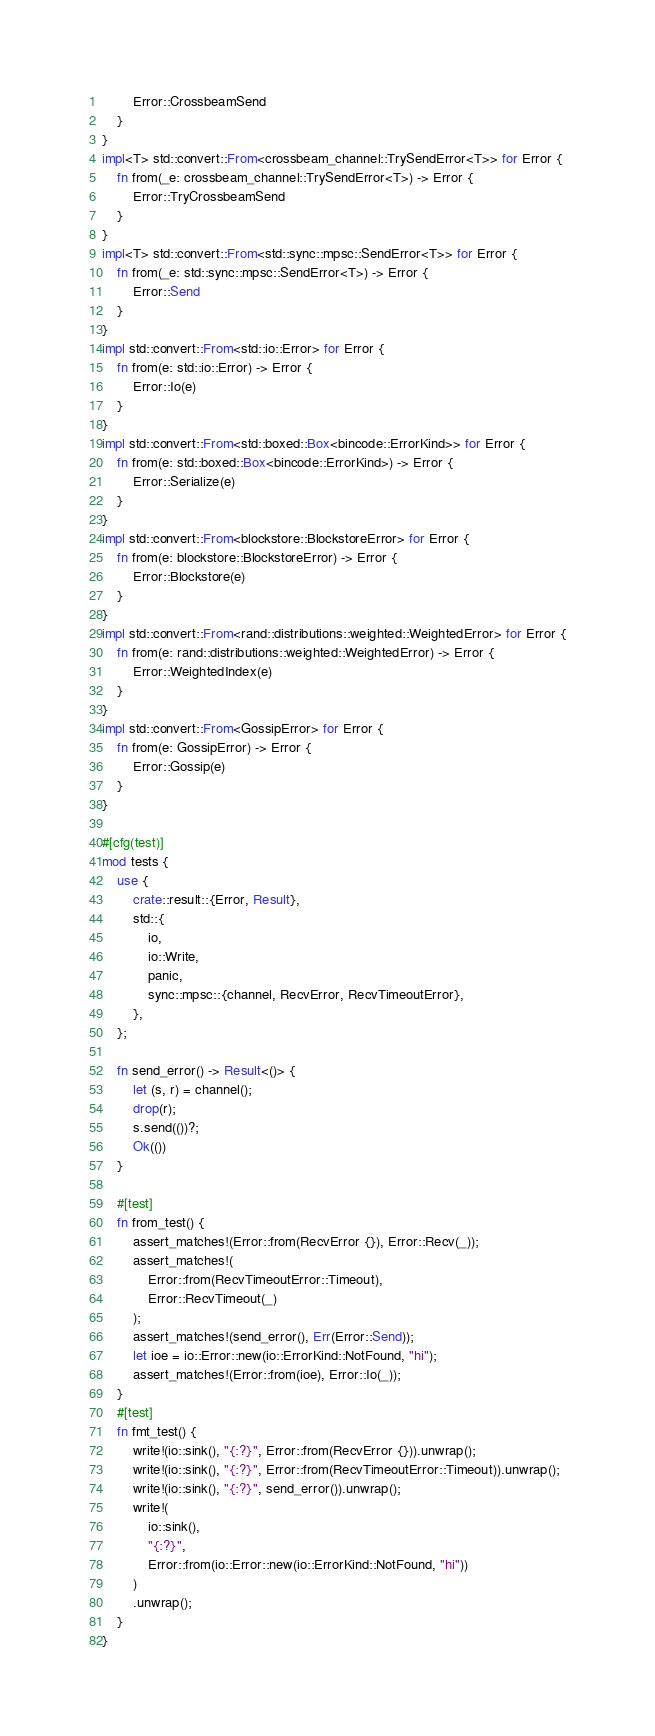Convert code to text. <code><loc_0><loc_0><loc_500><loc_500><_Rust_>        Error::CrossbeamSend
    }
}
impl<T> std::convert::From<crossbeam_channel::TrySendError<T>> for Error {
    fn from(_e: crossbeam_channel::TrySendError<T>) -> Error {
        Error::TryCrossbeamSend
    }
}
impl<T> std::convert::From<std::sync::mpsc::SendError<T>> for Error {
    fn from(_e: std::sync::mpsc::SendError<T>) -> Error {
        Error::Send
    }
}
impl std::convert::From<std::io::Error> for Error {
    fn from(e: std::io::Error) -> Error {
        Error::Io(e)
    }
}
impl std::convert::From<std::boxed::Box<bincode::ErrorKind>> for Error {
    fn from(e: std::boxed::Box<bincode::ErrorKind>) -> Error {
        Error::Serialize(e)
    }
}
impl std::convert::From<blockstore::BlockstoreError> for Error {
    fn from(e: blockstore::BlockstoreError) -> Error {
        Error::Blockstore(e)
    }
}
impl std::convert::From<rand::distributions::weighted::WeightedError> for Error {
    fn from(e: rand::distributions::weighted::WeightedError) -> Error {
        Error::WeightedIndex(e)
    }
}
impl std::convert::From<GossipError> for Error {
    fn from(e: GossipError) -> Error {
        Error::Gossip(e)
    }
}

#[cfg(test)]
mod tests {
    use {
        crate::result::{Error, Result},
        std::{
            io,
            io::Write,
            panic,
            sync::mpsc::{channel, RecvError, RecvTimeoutError},
        },
    };

    fn send_error() -> Result<()> {
        let (s, r) = channel();
        drop(r);
        s.send(())?;
        Ok(())
    }

    #[test]
    fn from_test() {
        assert_matches!(Error::from(RecvError {}), Error::Recv(_));
        assert_matches!(
            Error::from(RecvTimeoutError::Timeout),
            Error::RecvTimeout(_)
        );
        assert_matches!(send_error(), Err(Error::Send));
        let ioe = io::Error::new(io::ErrorKind::NotFound, "hi");
        assert_matches!(Error::from(ioe), Error::Io(_));
    }
    #[test]
    fn fmt_test() {
        write!(io::sink(), "{:?}", Error::from(RecvError {})).unwrap();
        write!(io::sink(), "{:?}", Error::from(RecvTimeoutError::Timeout)).unwrap();
        write!(io::sink(), "{:?}", send_error()).unwrap();
        write!(
            io::sink(),
            "{:?}",
            Error::from(io::Error::new(io::ErrorKind::NotFound, "hi"))
        )
        .unwrap();
    }
}
</code> 